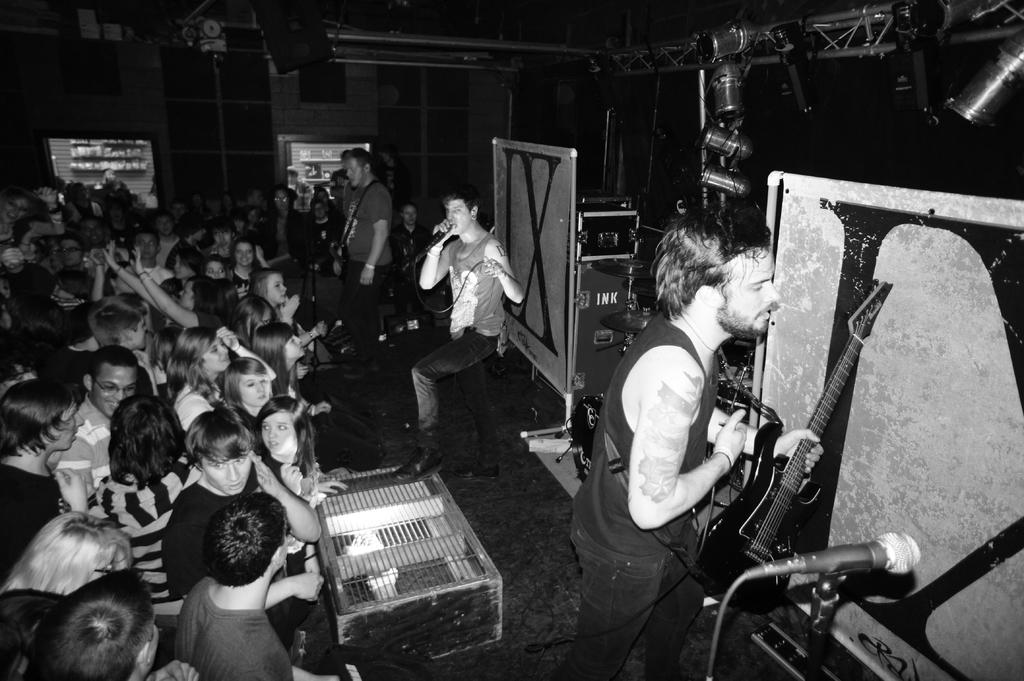How many people are in the image? There are people in the image. What is the man sitting down doing? The man sitting down is holding a mic. What is the man standing up doing? The man standing up is holding a guitar. What type of horn can be seen on the man's head in the image? There is no horn visible on anyone's head in the image. Are the people in the image wearing stockings? There is no information about stockings or any clothing items worn by the people in the image. 